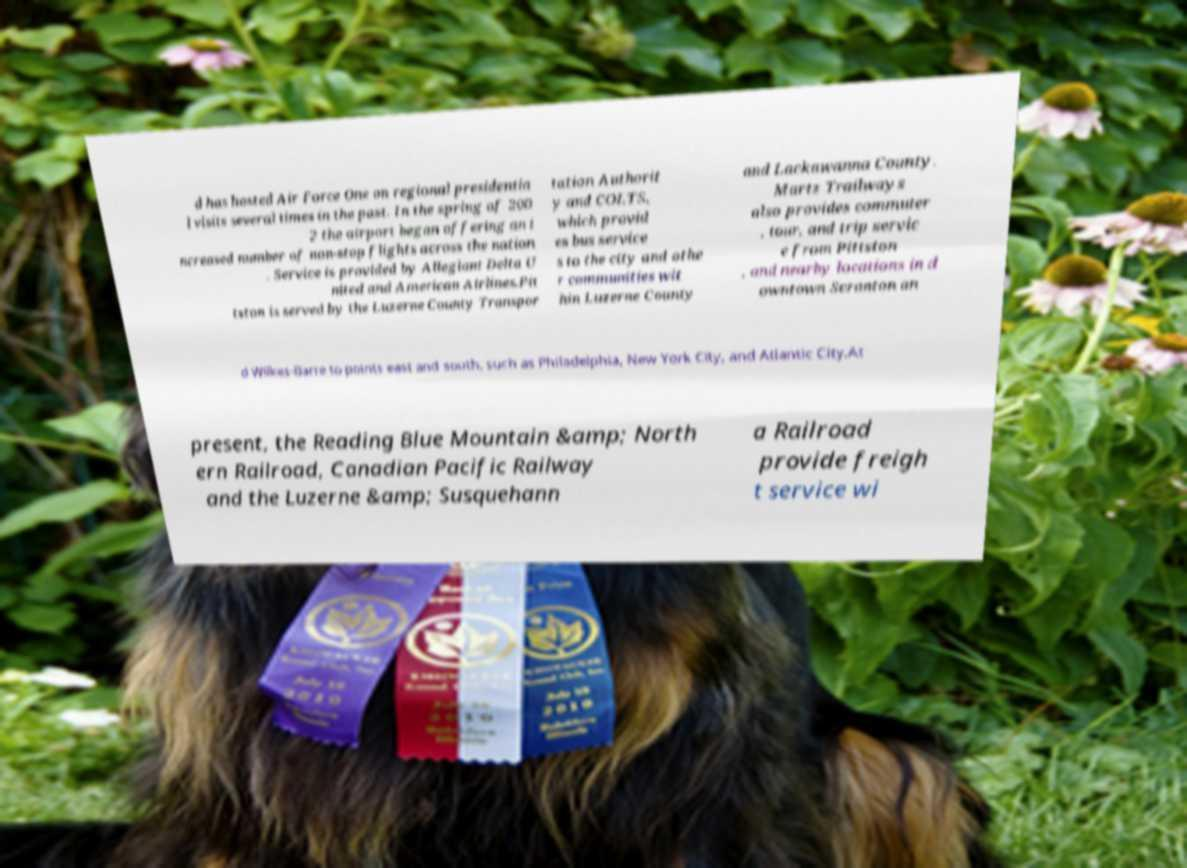I need the written content from this picture converted into text. Can you do that? d has hosted Air Force One on regional presidentia l visits several times in the past. In the spring of 200 2 the airport began offering an i ncreased number of non-stop flights across the nation . Service is provided by Allegiant Delta U nited and American Airlines.Pit tston is served by the Luzerne County Transpor tation Authorit y and COLTS, which provid es bus service s to the city and othe r communities wit hin Luzerne County and Lackawanna County. Martz Trailways also provides commuter , tour, and trip servic e from Pittston , and nearby locations in d owntown Scranton an d Wilkes-Barre to points east and south, such as Philadelphia, New York City, and Atlantic City.At present, the Reading Blue Mountain &amp; North ern Railroad, Canadian Pacific Railway and the Luzerne &amp; Susquehann a Railroad provide freigh t service wi 